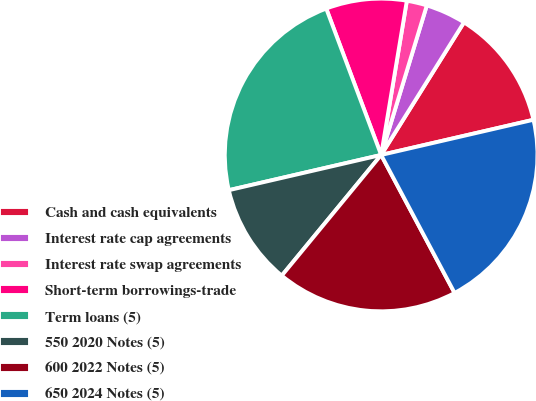Convert chart to OTSL. <chart><loc_0><loc_0><loc_500><loc_500><pie_chart><fcel>Cash and cash equivalents<fcel>Interest rate cap agreements<fcel>Interest rate swap agreements<fcel>Short-term borrowings-trade<fcel>Term loans (5)<fcel>550 2020 Notes (5)<fcel>600 2022 Notes (5)<fcel>650 2024 Notes (5)<nl><fcel>12.5%<fcel>4.17%<fcel>2.09%<fcel>8.34%<fcel>22.91%<fcel>10.42%<fcel>18.75%<fcel>20.83%<nl></chart> 